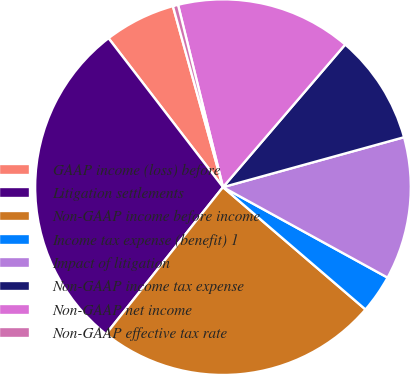Convert chart. <chart><loc_0><loc_0><loc_500><loc_500><pie_chart><fcel>GAAP income (loss) before<fcel>Litigation settlements<fcel>Non-GAAP income before income<fcel>Income tax expense (benefit) 1<fcel>Impact of litigation<fcel>Non-GAAP income tax expense<fcel>Non-GAAP net income<fcel>Non-GAAP effective tax rate<nl><fcel>6.13%<fcel>28.87%<fcel>24.41%<fcel>3.29%<fcel>12.28%<fcel>9.44%<fcel>15.12%<fcel>0.45%<nl></chart> 